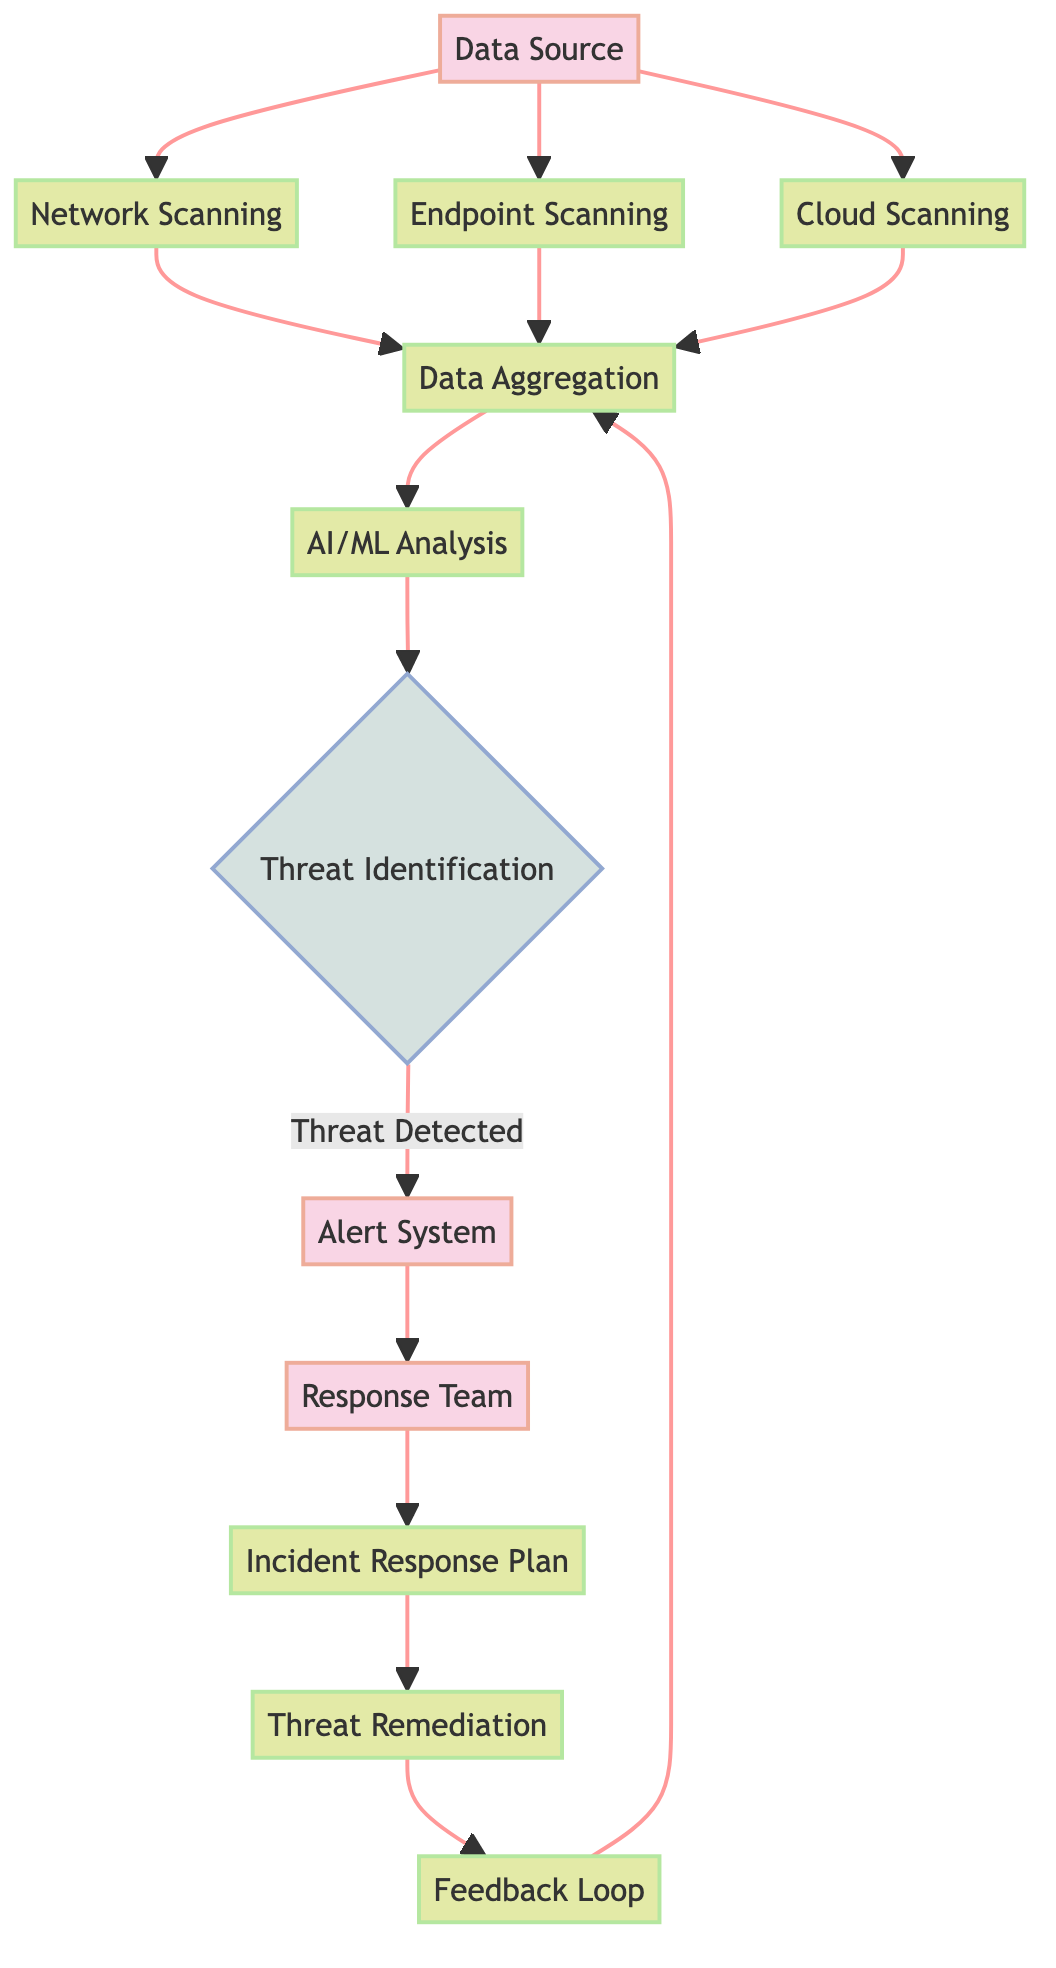What is the origin point of the data in the diagram? The diagram identifies "Data Source" as the origin point where user activities, server logs, and network traffic originate, as indicated in the description of this node.
Answer: Data Source Which processes utilize data from the "Data Source"? The "Data Source" connects to three processes: "Network Scanning," "Endpoint Scanning," and "Cloud Scanning," showing that all three utilize data from this source.
Answer: Network Scanning, Endpoint Scanning, Cloud Scanning How many types of nodes are present in the diagram? There are three types of nodes in the diagram: entity, process, and decision. Each node type categorizes different components in the threat detection workflow.
Answer: Three What happens after "AI/ML Analysis" if a threat is detected? Following "AI/ML Analysis," if a threat is detected, the flow proceeds to the "Alert System," which indicates the communication of identified threats to relevant teams.
Answer: Alert System How does the feedback mechanism operate in the diagram? The feedback loop operates by feeding information about previously detected and mitigated threats back into the "Data Aggregation" process, allowing for continuous improvement in the system.
Answer: Feedback Loop What type of system generates alerts upon threat detection? The "Alert System" is the entity responsible for generating and disseminating alerts to notify relevant teams of identified threats, as per its labeling in the diagram.
Answer: Alert System Which node represents the team tasked with responding to threats? The "Response Team" is specifically labeled in the diagram as the group of security experts responsible for responding to and mitigating identified threats.
Answer: Response Team What is the final step after "Threat Remediation"? The final step after "Threat Remediation" is to connect to the "Feedback Loop," which ensures that information from the incident response is utilized for system improvement.
Answer: Feedback Loop How many data flows are there connecting to "Data Aggregation"? There are three data flows connecting to "Data Aggregation" from "Network Scanning," "Endpoint Scanning," and "Cloud Scanning," indicating shared inputs for aggregation.
Answer: Three 